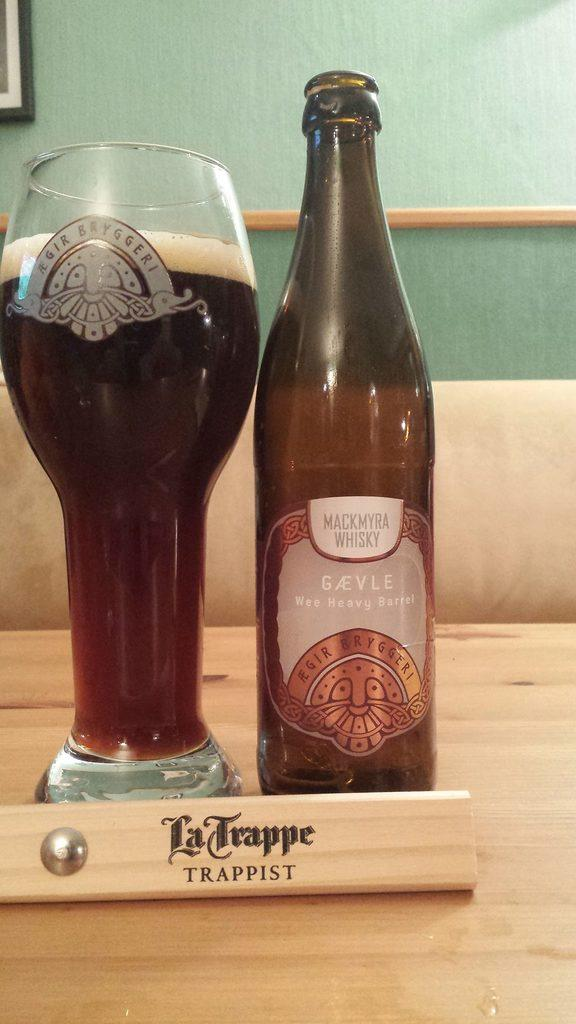What type of beverage is featured in the image? There is a wine bottle and a glass filled with wine in the image. What is the purpose of the display card in the image? The display card with text in the image is likely used for providing information about the wine. What can be seen on the wall in the image? There is a frame visible on the wall in the image. Can you describe the frame in the image? The frame in the image is likely used for displaying artwork or photographs. How many arms are visible in the image? There are no arms visible in the image. What type of umbrella is being used to protect the wine from sunlight in the image? There is no umbrella present in the image; the wine is not being protected from sunlight. 